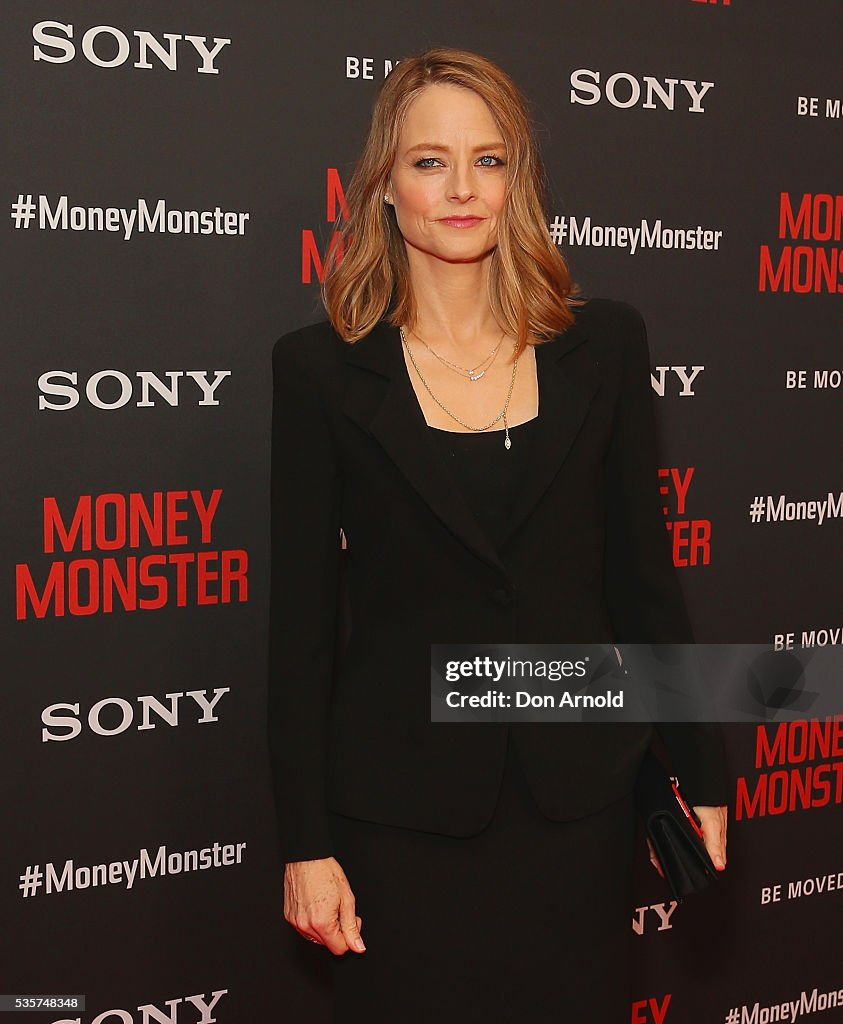What might the background elements tell us about the context and purpose of the event? The background elements, prominently displaying the title 'Money Monster' and logos from companies like Sony, suggest that the event is likely a promotional or premiere event for the movie 'Money Monster.' These kinds of backdrops are commonly used in media-related events to generate publicity and provide a branded setting for photographs and interviews. Can you provide more insights into what kind of guests might be attending such an event? Events like movie premieres typically attract a variety of guests, including actors, directors, producers, and other crew members involved in the film. Additionally, such events might host celebrities from the entertainment industry, media personnel, journalists, and invited VIPs. Movie premieres are glamorous affairs designed to garner media attention, so guests usually dress in formal or stylish attire, similar to the classic and refined outfit worn by the individual in the image. Imagine if this event was set in a fantastical world where movies were projected by magical beings. How might the scene look different? In a fantastical world where movies are projected by magical beings, the scene could be dramatically different. The backdrop might feature shimmering, animated images of magical creatures instead of static logos. The carpet could be made of luminescent, ever-changing colors as if crafted from enchanted materials. Guests might arrive on floating carriages or mythical beasts, dressed in robes woven from moonlight and stardust. Instead of cameras with flashes, there might be ethereal orbs floating around, capturing images with a gentle glow. The entire atmosphere would exude an otherworldly charm, turning the event into a spectacle of magic and wonder. 